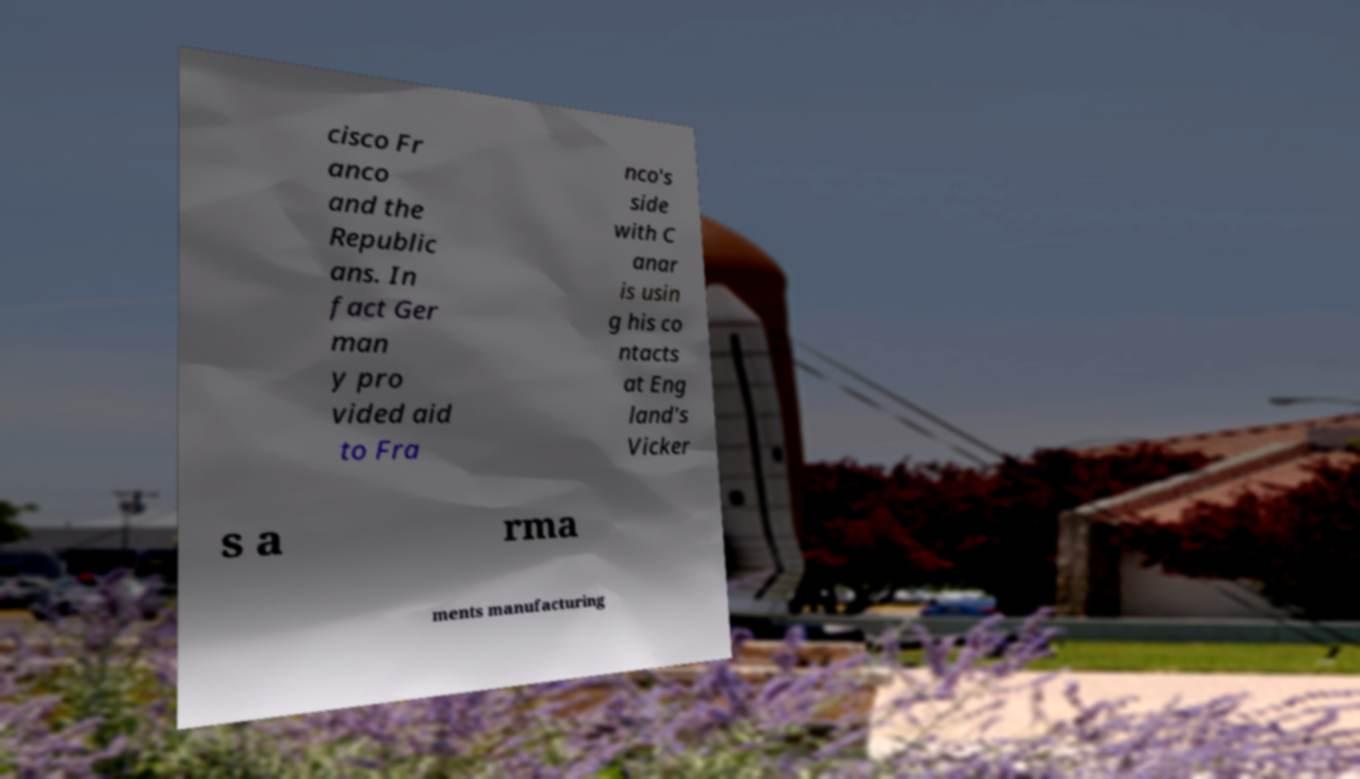For documentation purposes, I need the text within this image transcribed. Could you provide that? cisco Fr anco and the Republic ans. In fact Ger man y pro vided aid to Fra nco's side with C anar is usin g his co ntacts at Eng land's Vicker s a rma ments manufacturing 